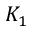Convert formula to latex. <formula><loc_0><loc_0><loc_500><loc_500>K _ { 1 }</formula> 